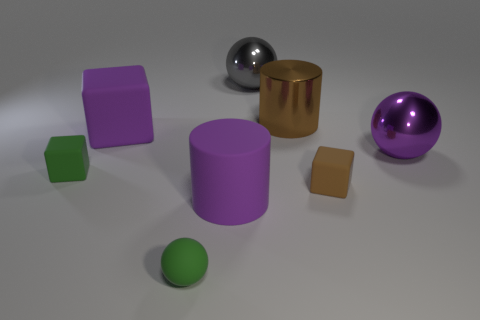Subtract all green balls. How many balls are left? 2 Subtract all brown blocks. How many blocks are left? 2 Subtract 1 cylinders. How many cylinders are left? 1 Add 2 tiny blocks. How many objects exist? 10 Subtract all spheres. How many objects are left? 5 Subtract all blue blocks. How many brown spheres are left? 0 Subtract 1 brown cubes. How many objects are left? 7 Subtract all gray cylinders. Subtract all cyan balls. How many cylinders are left? 2 Subtract all large purple cylinders. Subtract all brown metallic cylinders. How many objects are left? 6 Add 5 big purple matte cylinders. How many big purple matte cylinders are left? 6 